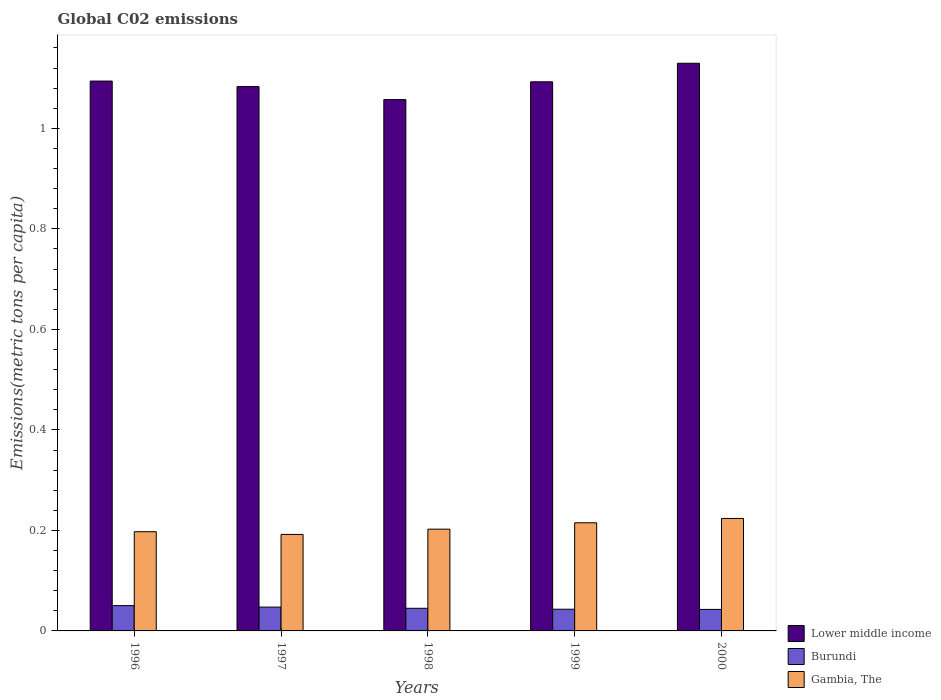How many different coloured bars are there?
Give a very brief answer. 3. Are the number of bars on each tick of the X-axis equal?
Give a very brief answer. Yes. How many bars are there on the 4th tick from the left?
Make the answer very short. 3. What is the label of the 1st group of bars from the left?
Ensure brevity in your answer.  1996. In how many cases, is the number of bars for a given year not equal to the number of legend labels?
Your answer should be compact. 0. What is the amount of CO2 emitted in in Gambia, The in 2000?
Your answer should be very brief. 0.22. Across all years, what is the maximum amount of CO2 emitted in in Burundi?
Offer a terse response. 0.05. Across all years, what is the minimum amount of CO2 emitted in in Gambia, The?
Make the answer very short. 0.19. In which year was the amount of CO2 emitted in in Lower middle income maximum?
Give a very brief answer. 2000. In which year was the amount of CO2 emitted in in Burundi minimum?
Provide a succinct answer. 2000. What is the total amount of CO2 emitted in in Lower middle income in the graph?
Your answer should be very brief. 5.46. What is the difference between the amount of CO2 emitted in in Burundi in 1997 and that in 1998?
Your answer should be compact. 0. What is the difference between the amount of CO2 emitted in in Burundi in 1997 and the amount of CO2 emitted in in Gambia, The in 1999?
Provide a succinct answer. -0.17. What is the average amount of CO2 emitted in in Burundi per year?
Give a very brief answer. 0.05. In the year 1999, what is the difference between the amount of CO2 emitted in in Burundi and amount of CO2 emitted in in Gambia, The?
Your response must be concise. -0.17. What is the ratio of the amount of CO2 emitted in in Lower middle income in 1997 to that in 2000?
Offer a very short reply. 0.96. Is the amount of CO2 emitted in in Gambia, The in 1996 less than that in 2000?
Offer a terse response. Yes. What is the difference between the highest and the second highest amount of CO2 emitted in in Burundi?
Offer a very short reply. 0. What is the difference between the highest and the lowest amount of CO2 emitted in in Gambia, The?
Your answer should be compact. 0.03. Is the sum of the amount of CO2 emitted in in Gambia, The in 1996 and 2000 greater than the maximum amount of CO2 emitted in in Lower middle income across all years?
Provide a short and direct response. No. What does the 3rd bar from the left in 1999 represents?
Your response must be concise. Gambia, The. What does the 3rd bar from the right in 1997 represents?
Offer a very short reply. Lower middle income. Is it the case that in every year, the sum of the amount of CO2 emitted in in Gambia, The and amount of CO2 emitted in in Burundi is greater than the amount of CO2 emitted in in Lower middle income?
Your answer should be very brief. No. How many bars are there?
Your response must be concise. 15. Are all the bars in the graph horizontal?
Make the answer very short. No. Are the values on the major ticks of Y-axis written in scientific E-notation?
Your answer should be very brief. No. Where does the legend appear in the graph?
Your response must be concise. Bottom right. What is the title of the graph?
Keep it short and to the point. Global C02 emissions. Does "Bosnia and Herzegovina" appear as one of the legend labels in the graph?
Offer a terse response. No. What is the label or title of the Y-axis?
Provide a succinct answer. Emissions(metric tons per capita). What is the Emissions(metric tons per capita) of Lower middle income in 1996?
Give a very brief answer. 1.09. What is the Emissions(metric tons per capita) in Burundi in 1996?
Provide a short and direct response. 0.05. What is the Emissions(metric tons per capita) in Gambia, The in 1996?
Give a very brief answer. 0.2. What is the Emissions(metric tons per capita) in Lower middle income in 1997?
Keep it short and to the point. 1.08. What is the Emissions(metric tons per capita) in Burundi in 1997?
Keep it short and to the point. 0.05. What is the Emissions(metric tons per capita) of Gambia, The in 1997?
Provide a succinct answer. 0.19. What is the Emissions(metric tons per capita) in Lower middle income in 1998?
Keep it short and to the point. 1.06. What is the Emissions(metric tons per capita) of Burundi in 1998?
Your answer should be compact. 0.05. What is the Emissions(metric tons per capita) in Gambia, The in 1998?
Your response must be concise. 0.2. What is the Emissions(metric tons per capita) in Lower middle income in 1999?
Offer a terse response. 1.09. What is the Emissions(metric tons per capita) in Burundi in 1999?
Give a very brief answer. 0.04. What is the Emissions(metric tons per capita) of Gambia, The in 1999?
Give a very brief answer. 0.22. What is the Emissions(metric tons per capita) in Lower middle income in 2000?
Offer a very short reply. 1.13. What is the Emissions(metric tons per capita) of Burundi in 2000?
Give a very brief answer. 0.04. What is the Emissions(metric tons per capita) in Gambia, The in 2000?
Offer a very short reply. 0.22. Across all years, what is the maximum Emissions(metric tons per capita) of Lower middle income?
Give a very brief answer. 1.13. Across all years, what is the maximum Emissions(metric tons per capita) in Burundi?
Offer a terse response. 0.05. Across all years, what is the maximum Emissions(metric tons per capita) in Gambia, The?
Offer a very short reply. 0.22. Across all years, what is the minimum Emissions(metric tons per capita) of Lower middle income?
Offer a very short reply. 1.06. Across all years, what is the minimum Emissions(metric tons per capita) of Burundi?
Provide a succinct answer. 0.04. Across all years, what is the minimum Emissions(metric tons per capita) in Gambia, The?
Provide a short and direct response. 0.19. What is the total Emissions(metric tons per capita) of Lower middle income in the graph?
Ensure brevity in your answer.  5.46. What is the total Emissions(metric tons per capita) in Burundi in the graph?
Offer a very short reply. 0.23. What is the total Emissions(metric tons per capita) of Gambia, The in the graph?
Your response must be concise. 1.03. What is the difference between the Emissions(metric tons per capita) in Lower middle income in 1996 and that in 1997?
Provide a succinct answer. 0.01. What is the difference between the Emissions(metric tons per capita) in Burundi in 1996 and that in 1997?
Your response must be concise. 0. What is the difference between the Emissions(metric tons per capita) of Gambia, The in 1996 and that in 1997?
Offer a terse response. 0.01. What is the difference between the Emissions(metric tons per capita) in Lower middle income in 1996 and that in 1998?
Provide a short and direct response. 0.04. What is the difference between the Emissions(metric tons per capita) in Burundi in 1996 and that in 1998?
Your answer should be compact. 0.01. What is the difference between the Emissions(metric tons per capita) in Gambia, The in 1996 and that in 1998?
Provide a short and direct response. -0.01. What is the difference between the Emissions(metric tons per capita) in Lower middle income in 1996 and that in 1999?
Your answer should be compact. 0. What is the difference between the Emissions(metric tons per capita) of Burundi in 1996 and that in 1999?
Offer a terse response. 0.01. What is the difference between the Emissions(metric tons per capita) in Gambia, The in 1996 and that in 1999?
Offer a very short reply. -0.02. What is the difference between the Emissions(metric tons per capita) in Lower middle income in 1996 and that in 2000?
Your answer should be compact. -0.04. What is the difference between the Emissions(metric tons per capita) of Burundi in 1996 and that in 2000?
Your answer should be compact. 0.01. What is the difference between the Emissions(metric tons per capita) in Gambia, The in 1996 and that in 2000?
Make the answer very short. -0.03. What is the difference between the Emissions(metric tons per capita) of Lower middle income in 1997 and that in 1998?
Offer a very short reply. 0.03. What is the difference between the Emissions(metric tons per capita) in Burundi in 1997 and that in 1998?
Ensure brevity in your answer.  0. What is the difference between the Emissions(metric tons per capita) in Gambia, The in 1997 and that in 1998?
Offer a very short reply. -0.01. What is the difference between the Emissions(metric tons per capita) of Lower middle income in 1997 and that in 1999?
Offer a terse response. -0.01. What is the difference between the Emissions(metric tons per capita) of Burundi in 1997 and that in 1999?
Offer a very short reply. 0. What is the difference between the Emissions(metric tons per capita) of Gambia, The in 1997 and that in 1999?
Ensure brevity in your answer.  -0.02. What is the difference between the Emissions(metric tons per capita) of Lower middle income in 1997 and that in 2000?
Your answer should be very brief. -0.05. What is the difference between the Emissions(metric tons per capita) of Burundi in 1997 and that in 2000?
Your response must be concise. 0. What is the difference between the Emissions(metric tons per capita) of Gambia, The in 1997 and that in 2000?
Offer a terse response. -0.03. What is the difference between the Emissions(metric tons per capita) in Lower middle income in 1998 and that in 1999?
Provide a short and direct response. -0.04. What is the difference between the Emissions(metric tons per capita) in Burundi in 1998 and that in 1999?
Your answer should be compact. 0. What is the difference between the Emissions(metric tons per capita) of Gambia, The in 1998 and that in 1999?
Offer a very short reply. -0.01. What is the difference between the Emissions(metric tons per capita) in Lower middle income in 1998 and that in 2000?
Offer a terse response. -0.07. What is the difference between the Emissions(metric tons per capita) in Burundi in 1998 and that in 2000?
Your answer should be very brief. 0. What is the difference between the Emissions(metric tons per capita) of Gambia, The in 1998 and that in 2000?
Your answer should be compact. -0.02. What is the difference between the Emissions(metric tons per capita) of Lower middle income in 1999 and that in 2000?
Your answer should be compact. -0.04. What is the difference between the Emissions(metric tons per capita) of Burundi in 1999 and that in 2000?
Give a very brief answer. 0. What is the difference between the Emissions(metric tons per capita) of Gambia, The in 1999 and that in 2000?
Keep it short and to the point. -0.01. What is the difference between the Emissions(metric tons per capita) of Lower middle income in 1996 and the Emissions(metric tons per capita) of Burundi in 1997?
Give a very brief answer. 1.05. What is the difference between the Emissions(metric tons per capita) of Lower middle income in 1996 and the Emissions(metric tons per capita) of Gambia, The in 1997?
Give a very brief answer. 0.9. What is the difference between the Emissions(metric tons per capita) in Burundi in 1996 and the Emissions(metric tons per capita) in Gambia, The in 1997?
Ensure brevity in your answer.  -0.14. What is the difference between the Emissions(metric tons per capita) of Lower middle income in 1996 and the Emissions(metric tons per capita) of Burundi in 1998?
Provide a succinct answer. 1.05. What is the difference between the Emissions(metric tons per capita) in Lower middle income in 1996 and the Emissions(metric tons per capita) in Gambia, The in 1998?
Your answer should be compact. 0.89. What is the difference between the Emissions(metric tons per capita) of Burundi in 1996 and the Emissions(metric tons per capita) of Gambia, The in 1998?
Your answer should be very brief. -0.15. What is the difference between the Emissions(metric tons per capita) in Lower middle income in 1996 and the Emissions(metric tons per capita) in Burundi in 1999?
Give a very brief answer. 1.05. What is the difference between the Emissions(metric tons per capita) of Lower middle income in 1996 and the Emissions(metric tons per capita) of Gambia, The in 1999?
Ensure brevity in your answer.  0.88. What is the difference between the Emissions(metric tons per capita) of Burundi in 1996 and the Emissions(metric tons per capita) of Gambia, The in 1999?
Your answer should be compact. -0.16. What is the difference between the Emissions(metric tons per capita) of Lower middle income in 1996 and the Emissions(metric tons per capita) of Burundi in 2000?
Offer a very short reply. 1.05. What is the difference between the Emissions(metric tons per capita) of Lower middle income in 1996 and the Emissions(metric tons per capita) of Gambia, The in 2000?
Your answer should be very brief. 0.87. What is the difference between the Emissions(metric tons per capita) of Burundi in 1996 and the Emissions(metric tons per capita) of Gambia, The in 2000?
Your answer should be very brief. -0.17. What is the difference between the Emissions(metric tons per capita) in Lower middle income in 1997 and the Emissions(metric tons per capita) in Burundi in 1998?
Your response must be concise. 1.04. What is the difference between the Emissions(metric tons per capita) of Lower middle income in 1997 and the Emissions(metric tons per capita) of Gambia, The in 1998?
Your answer should be compact. 0.88. What is the difference between the Emissions(metric tons per capita) in Burundi in 1997 and the Emissions(metric tons per capita) in Gambia, The in 1998?
Your answer should be very brief. -0.16. What is the difference between the Emissions(metric tons per capita) in Lower middle income in 1997 and the Emissions(metric tons per capita) in Burundi in 1999?
Provide a short and direct response. 1.04. What is the difference between the Emissions(metric tons per capita) in Lower middle income in 1997 and the Emissions(metric tons per capita) in Gambia, The in 1999?
Your response must be concise. 0.87. What is the difference between the Emissions(metric tons per capita) of Burundi in 1997 and the Emissions(metric tons per capita) of Gambia, The in 1999?
Offer a terse response. -0.17. What is the difference between the Emissions(metric tons per capita) of Lower middle income in 1997 and the Emissions(metric tons per capita) of Burundi in 2000?
Your answer should be very brief. 1.04. What is the difference between the Emissions(metric tons per capita) in Lower middle income in 1997 and the Emissions(metric tons per capita) in Gambia, The in 2000?
Keep it short and to the point. 0.86. What is the difference between the Emissions(metric tons per capita) of Burundi in 1997 and the Emissions(metric tons per capita) of Gambia, The in 2000?
Your answer should be compact. -0.18. What is the difference between the Emissions(metric tons per capita) in Lower middle income in 1998 and the Emissions(metric tons per capita) in Burundi in 1999?
Give a very brief answer. 1.01. What is the difference between the Emissions(metric tons per capita) in Lower middle income in 1998 and the Emissions(metric tons per capita) in Gambia, The in 1999?
Keep it short and to the point. 0.84. What is the difference between the Emissions(metric tons per capita) in Burundi in 1998 and the Emissions(metric tons per capita) in Gambia, The in 1999?
Provide a short and direct response. -0.17. What is the difference between the Emissions(metric tons per capita) in Lower middle income in 1998 and the Emissions(metric tons per capita) in Burundi in 2000?
Make the answer very short. 1.01. What is the difference between the Emissions(metric tons per capita) in Lower middle income in 1998 and the Emissions(metric tons per capita) in Gambia, The in 2000?
Give a very brief answer. 0.83. What is the difference between the Emissions(metric tons per capita) of Burundi in 1998 and the Emissions(metric tons per capita) of Gambia, The in 2000?
Make the answer very short. -0.18. What is the difference between the Emissions(metric tons per capita) of Lower middle income in 1999 and the Emissions(metric tons per capita) of Burundi in 2000?
Give a very brief answer. 1.05. What is the difference between the Emissions(metric tons per capita) in Lower middle income in 1999 and the Emissions(metric tons per capita) in Gambia, The in 2000?
Provide a short and direct response. 0.87. What is the difference between the Emissions(metric tons per capita) of Burundi in 1999 and the Emissions(metric tons per capita) of Gambia, The in 2000?
Offer a terse response. -0.18. What is the average Emissions(metric tons per capita) in Lower middle income per year?
Offer a terse response. 1.09. What is the average Emissions(metric tons per capita) of Burundi per year?
Provide a succinct answer. 0.05. What is the average Emissions(metric tons per capita) in Gambia, The per year?
Make the answer very short. 0.21. In the year 1996, what is the difference between the Emissions(metric tons per capita) of Lower middle income and Emissions(metric tons per capita) of Burundi?
Keep it short and to the point. 1.04. In the year 1996, what is the difference between the Emissions(metric tons per capita) of Lower middle income and Emissions(metric tons per capita) of Gambia, The?
Your answer should be compact. 0.9. In the year 1996, what is the difference between the Emissions(metric tons per capita) of Burundi and Emissions(metric tons per capita) of Gambia, The?
Your answer should be compact. -0.15. In the year 1997, what is the difference between the Emissions(metric tons per capita) in Lower middle income and Emissions(metric tons per capita) in Burundi?
Give a very brief answer. 1.04. In the year 1997, what is the difference between the Emissions(metric tons per capita) of Lower middle income and Emissions(metric tons per capita) of Gambia, The?
Your response must be concise. 0.89. In the year 1997, what is the difference between the Emissions(metric tons per capita) in Burundi and Emissions(metric tons per capita) in Gambia, The?
Keep it short and to the point. -0.14. In the year 1998, what is the difference between the Emissions(metric tons per capita) of Lower middle income and Emissions(metric tons per capita) of Burundi?
Give a very brief answer. 1.01. In the year 1998, what is the difference between the Emissions(metric tons per capita) of Lower middle income and Emissions(metric tons per capita) of Gambia, The?
Offer a terse response. 0.85. In the year 1998, what is the difference between the Emissions(metric tons per capita) in Burundi and Emissions(metric tons per capita) in Gambia, The?
Keep it short and to the point. -0.16. In the year 1999, what is the difference between the Emissions(metric tons per capita) in Lower middle income and Emissions(metric tons per capita) in Burundi?
Offer a terse response. 1.05. In the year 1999, what is the difference between the Emissions(metric tons per capita) in Lower middle income and Emissions(metric tons per capita) in Gambia, The?
Make the answer very short. 0.88. In the year 1999, what is the difference between the Emissions(metric tons per capita) of Burundi and Emissions(metric tons per capita) of Gambia, The?
Your answer should be compact. -0.17. In the year 2000, what is the difference between the Emissions(metric tons per capita) of Lower middle income and Emissions(metric tons per capita) of Burundi?
Provide a succinct answer. 1.09. In the year 2000, what is the difference between the Emissions(metric tons per capita) in Lower middle income and Emissions(metric tons per capita) in Gambia, The?
Offer a terse response. 0.91. In the year 2000, what is the difference between the Emissions(metric tons per capita) of Burundi and Emissions(metric tons per capita) of Gambia, The?
Offer a very short reply. -0.18. What is the ratio of the Emissions(metric tons per capita) in Lower middle income in 1996 to that in 1997?
Offer a very short reply. 1.01. What is the ratio of the Emissions(metric tons per capita) in Burundi in 1996 to that in 1997?
Keep it short and to the point. 1.06. What is the ratio of the Emissions(metric tons per capita) of Gambia, The in 1996 to that in 1997?
Offer a terse response. 1.03. What is the ratio of the Emissions(metric tons per capita) in Lower middle income in 1996 to that in 1998?
Keep it short and to the point. 1.03. What is the ratio of the Emissions(metric tons per capita) in Burundi in 1996 to that in 1998?
Offer a terse response. 1.12. What is the ratio of the Emissions(metric tons per capita) of Gambia, The in 1996 to that in 1998?
Your answer should be very brief. 0.97. What is the ratio of the Emissions(metric tons per capita) in Burundi in 1996 to that in 1999?
Offer a terse response. 1.17. What is the ratio of the Emissions(metric tons per capita) of Gambia, The in 1996 to that in 1999?
Your response must be concise. 0.92. What is the ratio of the Emissions(metric tons per capita) of Lower middle income in 1996 to that in 2000?
Offer a terse response. 0.97. What is the ratio of the Emissions(metric tons per capita) of Burundi in 1996 to that in 2000?
Make the answer very short. 1.18. What is the ratio of the Emissions(metric tons per capita) of Gambia, The in 1996 to that in 2000?
Offer a terse response. 0.88. What is the ratio of the Emissions(metric tons per capita) in Lower middle income in 1997 to that in 1998?
Give a very brief answer. 1.02. What is the ratio of the Emissions(metric tons per capita) in Burundi in 1997 to that in 1998?
Your answer should be compact. 1.05. What is the ratio of the Emissions(metric tons per capita) of Gambia, The in 1997 to that in 1998?
Provide a succinct answer. 0.95. What is the ratio of the Emissions(metric tons per capita) in Burundi in 1997 to that in 1999?
Your answer should be compact. 1.1. What is the ratio of the Emissions(metric tons per capita) of Gambia, The in 1997 to that in 1999?
Provide a succinct answer. 0.89. What is the ratio of the Emissions(metric tons per capita) of Lower middle income in 1997 to that in 2000?
Keep it short and to the point. 0.96. What is the ratio of the Emissions(metric tons per capita) of Burundi in 1997 to that in 2000?
Your answer should be compact. 1.11. What is the ratio of the Emissions(metric tons per capita) in Gambia, The in 1997 to that in 2000?
Keep it short and to the point. 0.86. What is the ratio of the Emissions(metric tons per capita) in Lower middle income in 1998 to that in 1999?
Offer a very short reply. 0.97. What is the ratio of the Emissions(metric tons per capita) in Burundi in 1998 to that in 1999?
Give a very brief answer. 1.04. What is the ratio of the Emissions(metric tons per capita) of Gambia, The in 1998 to that in 1999?
Offer a very short reply. 0.94. What is the ratio of the Emissions(metric tons per capita) of Lower middle income in 1998 to that in 2000?
Provide a short and direct response. 0.94. What is the ratio of the Emissions(metric tons per capita) of Burundi in 1998 to that in 2000?
Your answer should be compact. 1.05. What is the ratio of the Emissions(metric tons per capita) of Gambia, The in 1998 to that in 2000?
Provide a succinct answer. 0.9. What is the ratio of the Emissions(metric tons per capita) of Lower middle income in 1999 to that in 2000?
Your answer should be very brief. 0.97. What is the ratio of the Emissions(metric tons per capita) of Burundi in 1999 to that in 2000?
Give a very brief answer. 1.01. What is the ratio of the Emissions(metric tons per capita) of Gambia, The in 1999 to that in 2000?
Keep it short and to the point. 0.96. What is the difference between the highest and the second highest Emissions(metric tons per capita) of Lower middle income?
Your response must be concise. 0.04. What is the difference between the highest and the second highest Emissions(metric tons per capita) in Burundi?
Make the answer very short. 0. What is the difference between the highest and the second highest Emissions(metric tons per capita) of Gambia, The?
Ensure brevity in your answer.  0.01. What is the difference between the highest and the lowest Emissions(metric tons per capita) in Lower middle income?
Provide a short and direct response. 0.07. What is the difference between the highest and the lowest Emissions(metric tons per capita) of Burundi?
Ensure brevity in your answer.  0.01. What is the difference between the highest and the lowest Emissions(metric tons per capita) of Gambia, The?
Provide a succinct answer. 0.03. 